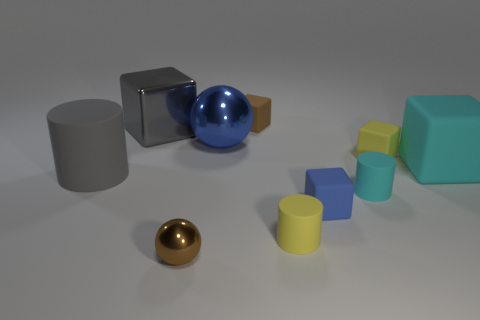Subtract all tiny rubber cylinders. How many cylinders are left? 1 Subtract all cyan blocks. How many blocks are left? 4 Subtract all spheres. How many objects are left? 8 Subtract all cyan cubes. How many gray cylinders are left? 1 Add 4 yellow blocks. How many yellow blocks are left? 5 Add 3 big gray matte things. How many big gray matte things exist? 4 Subtract 1 gray cylinders. How many objects are left? 9 Subtract 2 balls. How many balls are left? 0 Subtract all cyan blocks. Subtract all red cylinders. How many blocks are left? 4 Subtract all small yellow matte cubes. Subtract all brown metal objects. How many objects are left? 8 